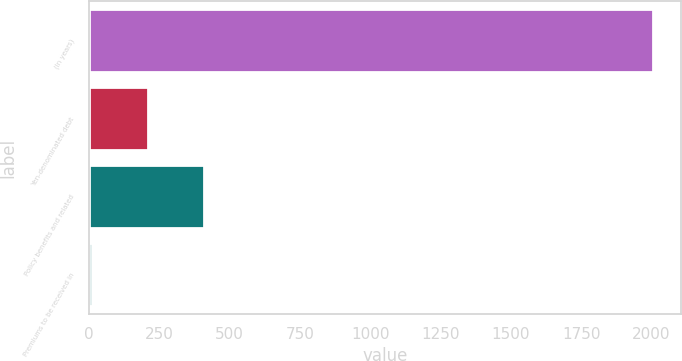Convert chart. <chart><loc_0><loc_0><loc_500><loc_500><bar_chart><fcel>(In years)<fcel>Yen-denominated debt<fcel>Policy benefits and related<fcel>Premiums to be received in<nl><fcel>2006<fcel>209.6<fcel>409.2<fcel>10<nl></chart> 